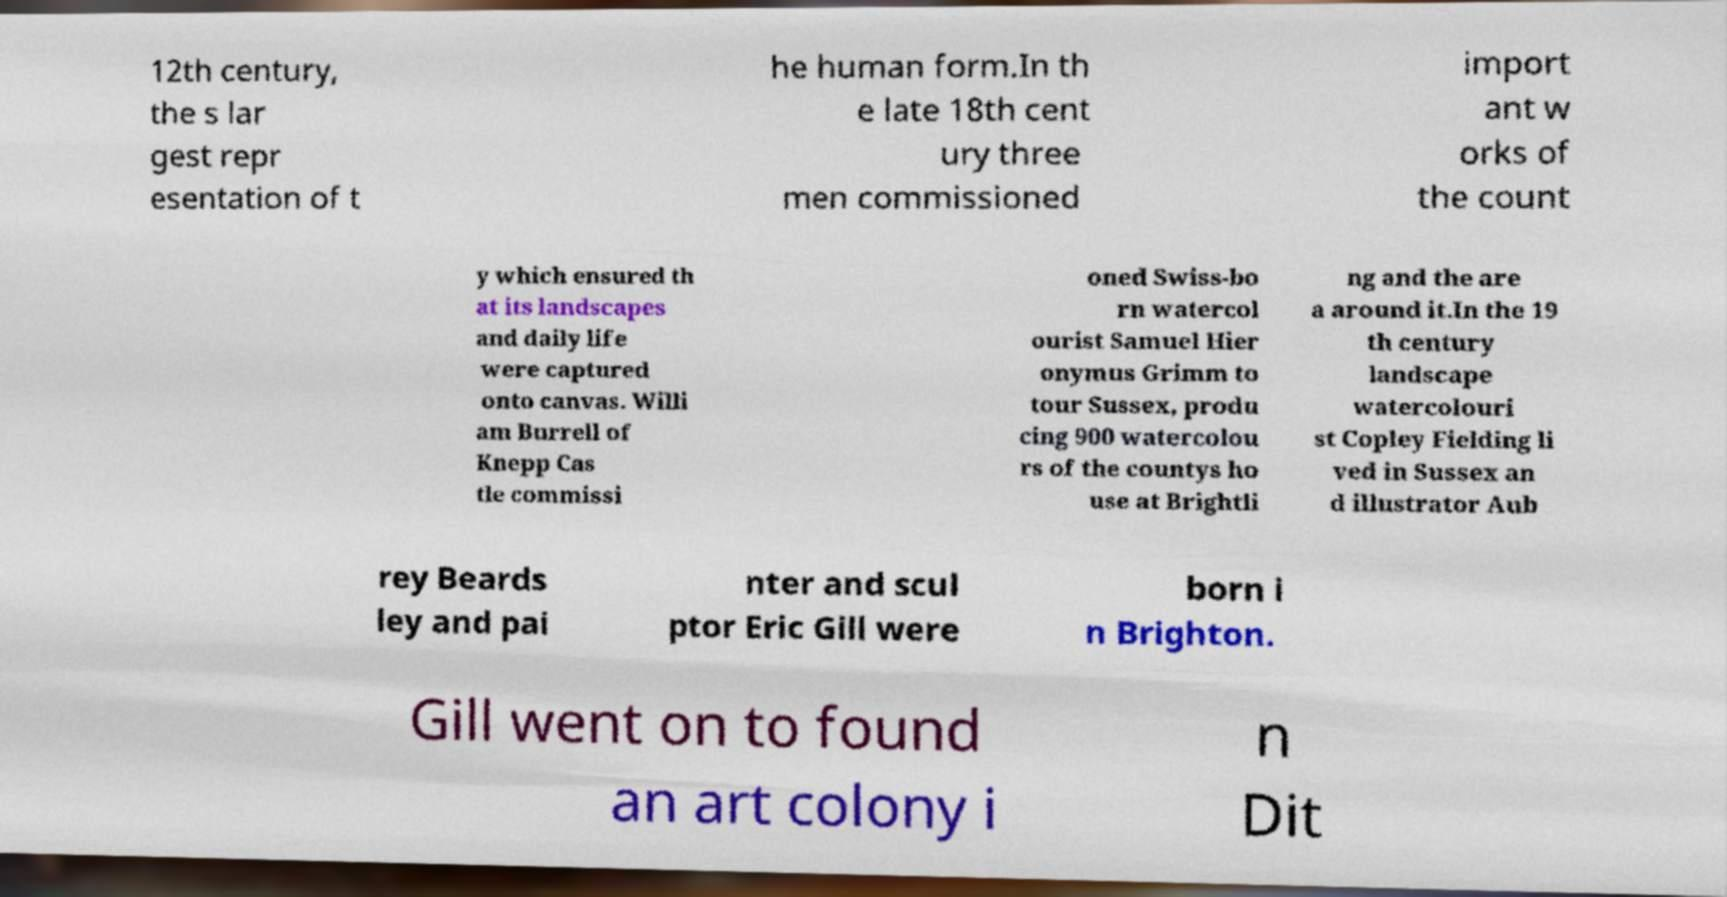Please read and relay the text visible in this image. What does it say? 12th century, the s lar gest repr esentation of t he human form.In th e late 18th cent ury three men commissioned import ant w orks of the count y which ensured th at its landscapes and daily life were captured onto canvas. Willi am Burrell of Knepp Cas tle commissi oned Swiss-bo rn watercol ourist Samuel Hier onymus Grimm to tour Sussex, produ cing 900 watercolou rs of the countys ho use at Brightli ng and the are a around it.In the 19 th century landscape watercolouri st Copley Fielding li ved in Sussex an d illustrator Aub rey Beards ley and pai nter and scul ptor Eric Gill were born i n Brighton. Gill went on to found an art colony i n Dit 